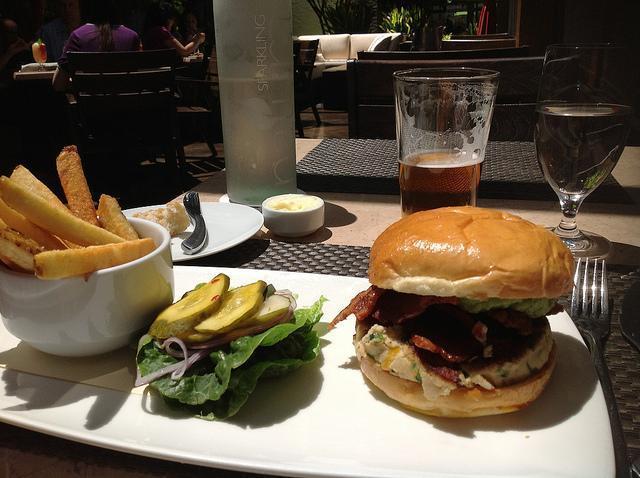Does the caption "The couch is far away from the sandwich." correctly depict the image?
Answer yes or no. Yes. 